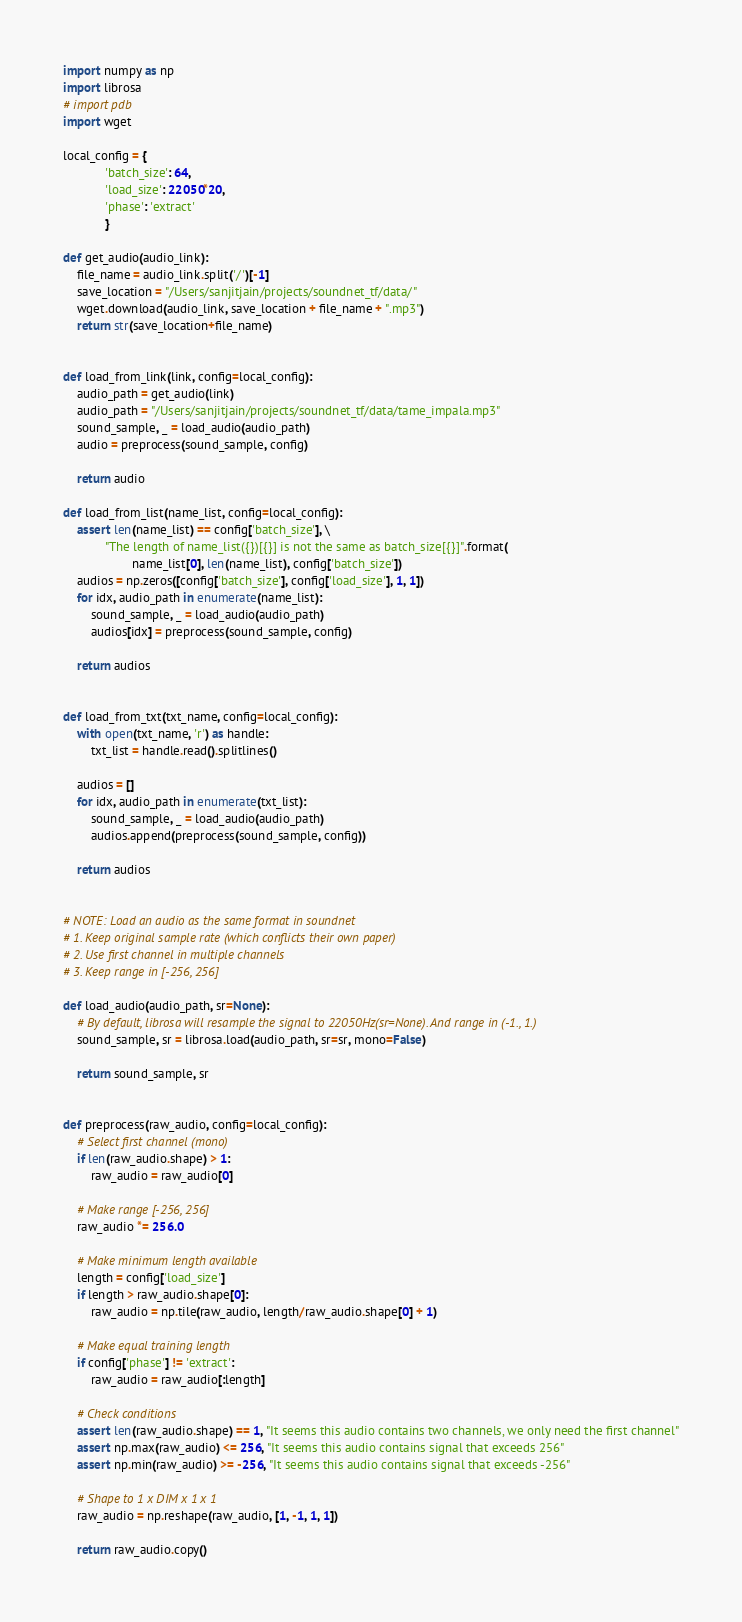Convert code to text. <code><loc_0><loc_0><loc_500><loc_500><_Python_>import numpy as np
import librosa
# import pdb
import wget

local_config = {
            'batch_size': 64, 
            'load_size': 22050*20,
            'phase': 'extract'
            }

def get_audio(audio_link):
    file_name = audio_link.split('/')[-1]
    save_location = "/Users/sanjitjain/projects/soundnet_tf/data/"
    wget.download(audio_link, save_location + file_name + ".mp3")
    return str(save_location+file_name)


def load_from_link(link, config=local_config):
    audio_path = get_audio(link)
    audio_path = "/Users/sanjitjain/projects/soundnet_tf/data/tame_impala.mp3"
    sound_sample, _ = load_audio(audio_path)
    audio = preprocess(sound_sample, config)

    return audio

def load_from_list(name_list, config=local_config):
    assert len(name_list) == config['batch_size'], \
            "The length of name_list({})[{}] is not the same as batch_size[{}]".format(
                    name_list[0], len(name_list), config['batch_size'])
    audios = np.zeros([config['batch_size'], config['load_size'], 1, 1])
    for idx, audio_path in enumerate(name_list):
        sound_sample, _ = load_audio(audio_path)
        audios[idx] = preprocess(sound_sample, config)
        
    return audios


def load_from_txt(txt_name, config=local_config):
    with open(txt_name, 'r') as handle:
        txt_list = handle.read().splitlines()

    audios = []
    for idx, audio_path in enumerate(txt_list):
        sound_sample, _ = load_audio(audio_path)
        audios.append(preprocess(sound_sample, config))
        
    return audios


# NOTE: Load an audio as the same format in soundnet
# 1. Keep original sample rate (which conflicts their own paper)
# 2. Use first channel in multiple channels
# 3. Keep range in [-256, 256]

def load_audio(audio_path, sr=None):
    # By default, librosa will resample the signal to 22050Hz(sr=None). And range in (-1., 1.)
    sound_sample, sr = librosa.load(audio_path, sr=sr, mono=False)

    return sound_sample, sr


def preprocess(raw_audio, config=local_config):
    # Select first channel (mono)
    if len(raw_audio.shape) > 1:
        raw_audio = raw_audio[0]

    # Make range [-256, 256]
    raw_audio *= 256.0

    # Make minimum length available
    length = config['load_size']
    if length > raw_audio.shape[0]:
        raw_audio = np.tile(raw_audio, length/raw_audio.shape[0] + 1)

    # Make equal training length
    if config['phase'] != 'extract':
        raw_audio = raw_audio[:length]

    # Check conditions
    assert len(raw_audio.shape) == 1, "It seems this audio contains two channels, we only need the first channel"
    assert np.max(raw_audio) <= 256, "It seems this audio contains signal that exceeds 256"
    assert np.min(raw_audio) >= -256, "It seems this audio contains signal that exceeds -256"

    # Shape to 1 x DIM x 1 x 1
    raw_audio = np.reshape(raw_audio, [1, -1, 1, 1])

    return raw_audio.copy()


</code> 